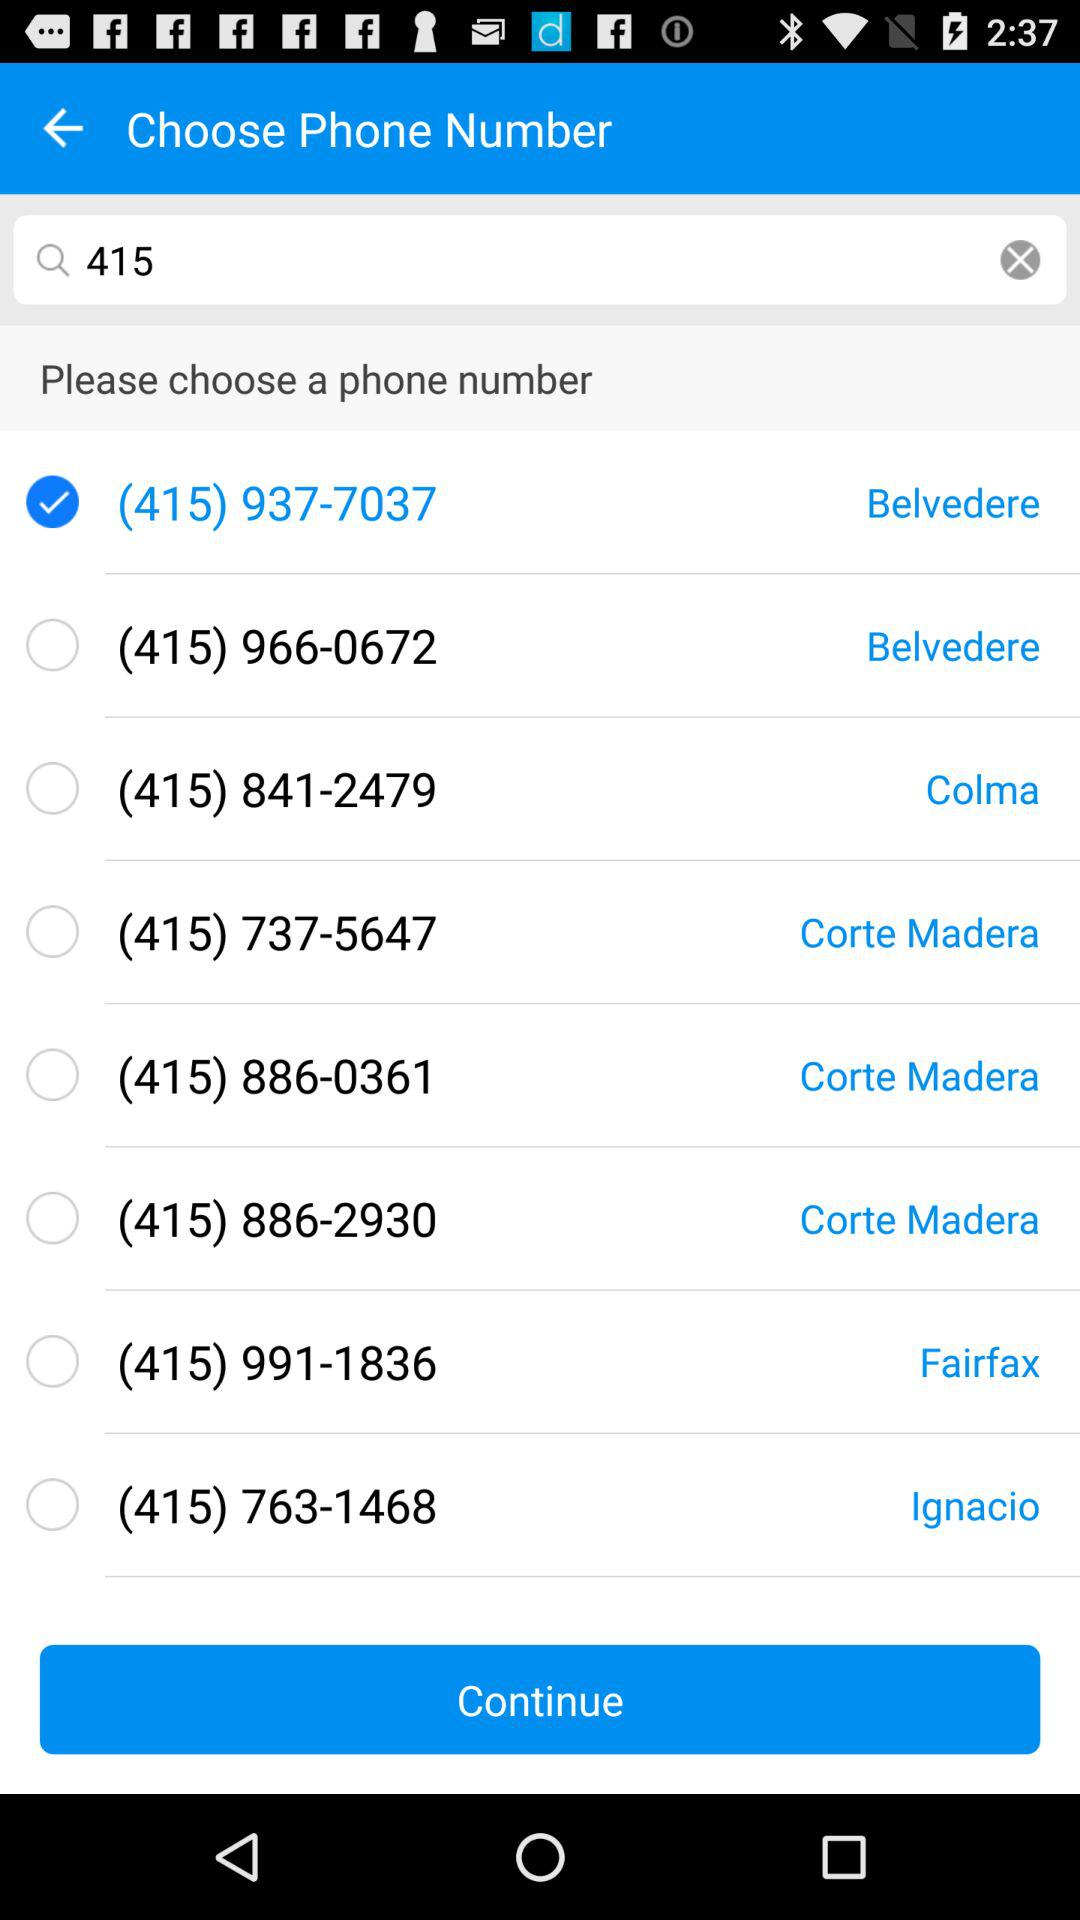To which location does the selected number belong? The selected number belongs to Belvedere. 